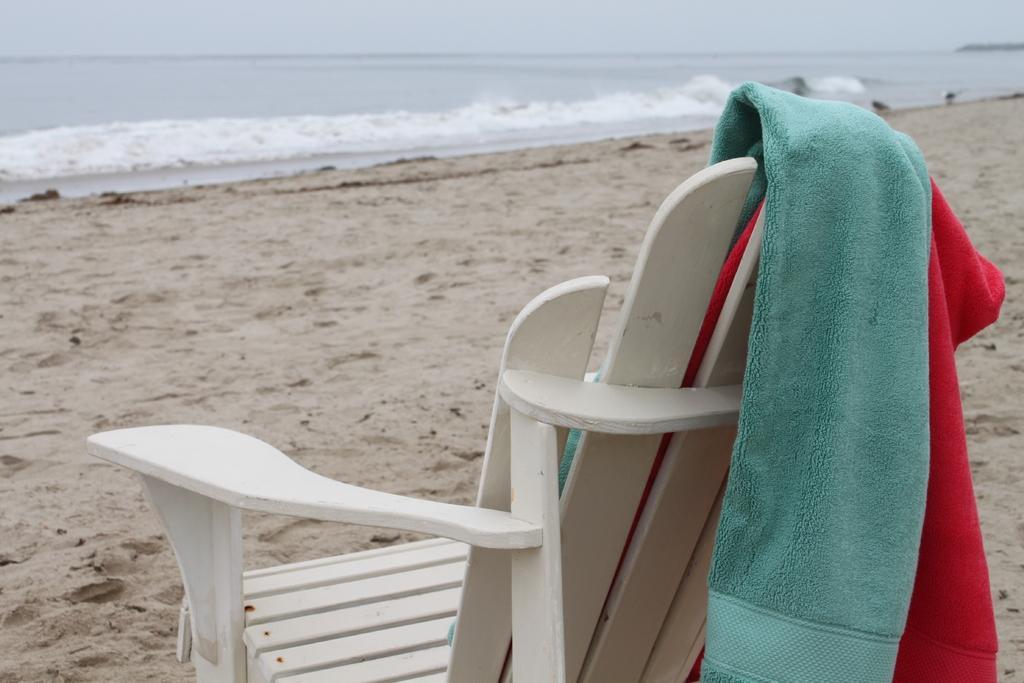Could you give a brief overview of what you see in this image? In this picture there is a white color chair in the beach. We can observe a cyan color and red color towels on the chair. In the background there is an ocean and a sky. 